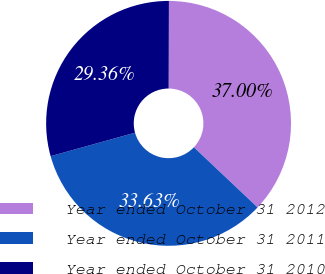Convert chart. <chart><loc_0><loc_0><loc_500><loc_500><pie_chart><fcel>Year ended October 31 2012<fcel>Year ended October 31 2011<fcel>Year ended October 31 2010<nl><fcel>37.0%<fcel>33.63%<fcel>29.36%<nl></chart> 